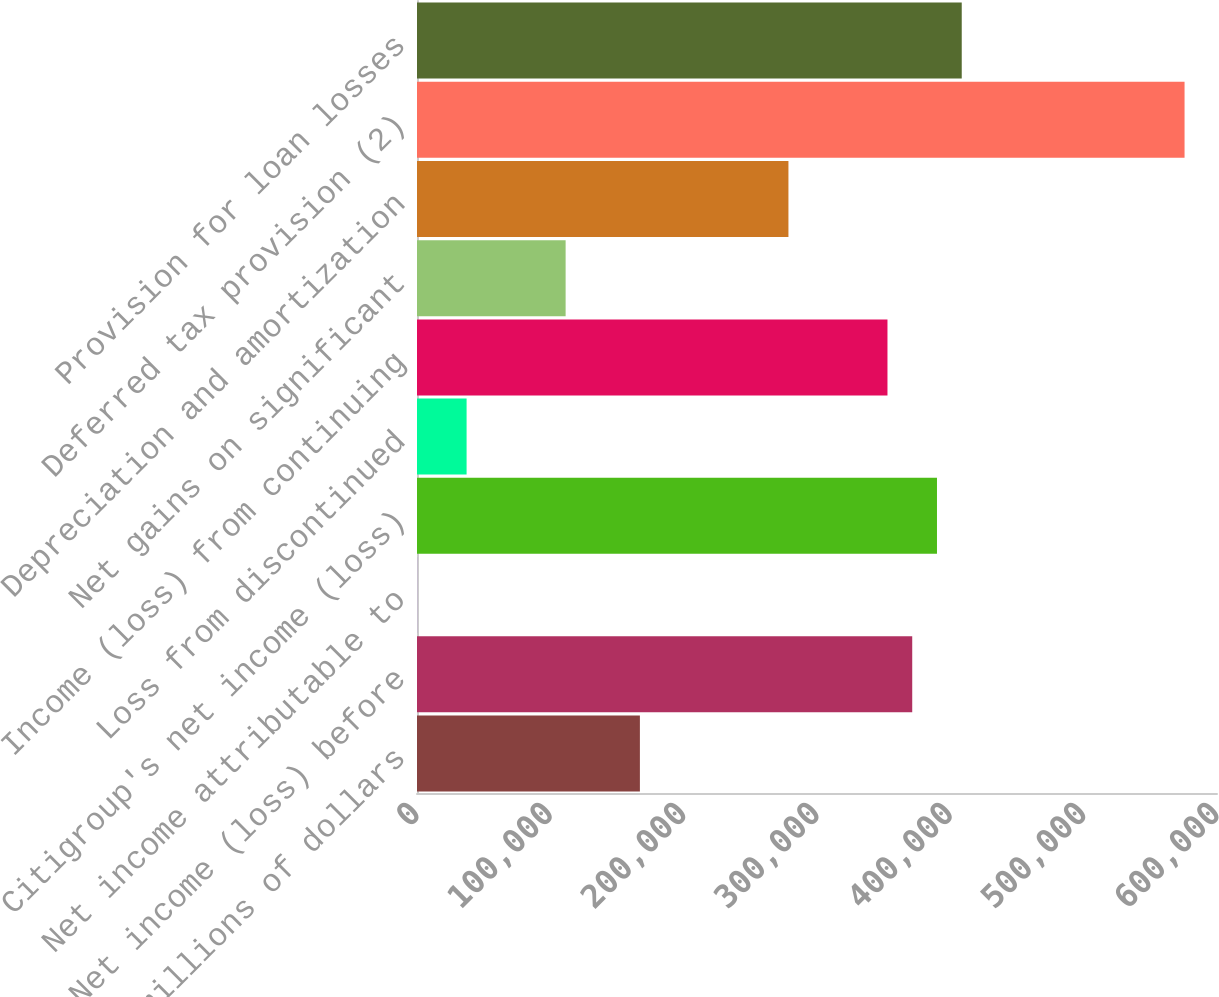Convert chart to OTSL. <chart><loc_0><loc_0><loc_500><loc_500><bar_chart><fcel>In millions of dollars<fcel>Net income (loss) before<fcel>Net income attributable to<fcel>Citigroup's net income (loss)<fcel>Loss from discontinued<fcel>Income (loss) from continuing<fcel>Net gains on significant<fcel>Depreciation and amortization<fcel>Deferred tax provision (2)<fcel>Provision for loan losses<nl><fcel>167172<fcel>371420<fcel>60<fcel>389988<fcel>37196<fcel>352852<fcel>111468<fcel>278580<fcel>575668<fcel>408556<nl></chart> 